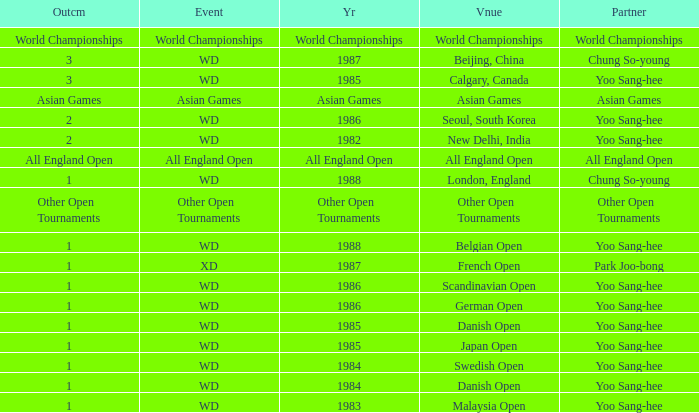What was the result of the wd event in 1983? 1.0. 